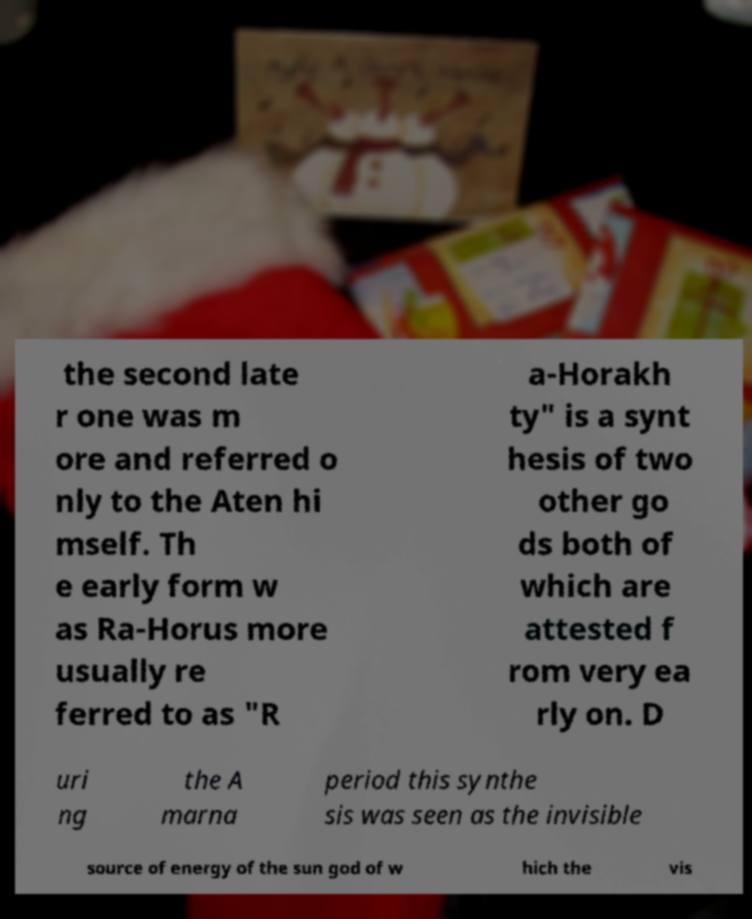There's text embedded in this image that I need extracted. Can you transcribe it verbatim? the second late r one was m ore and referred o nly to the Aten hi mself. Th e early form w as Ra-Horus more usually re ferred to as "R a-Horakh ty" is a synt hesis of two other go ds both of which are attested f rom very ea rly on. D uri ng the A marna period this synthe sis was seen as the invisible source of energy of the sun god of w hich the vis 